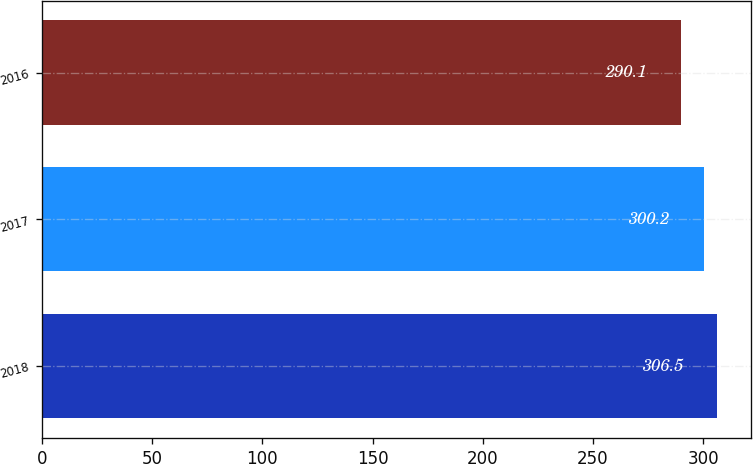Convert chart to OTSL. <chart><loc_0><loc_0><loc_500><loc_500><bar_chart><fcel>2018<fcel>2017<fcel>2016<nl><fcel>306.5<fcel>300.2<fcel>290.1<nl></chart> 